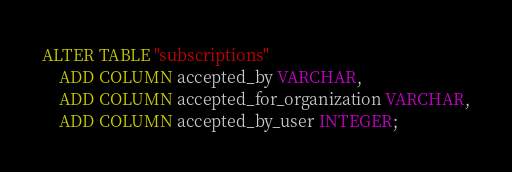Convert code to text. <code><loc_0><loc_0><loc_500><loc_500><_SQL_>ALTER TABLE "subscriptions"
	ADD COLUMN accepted_by VARCHAR,
	ADD COLUMN accepted_for_organization VARCHAR,
	ADD COLUMN accepted_by_user INTEGER;

</code> 